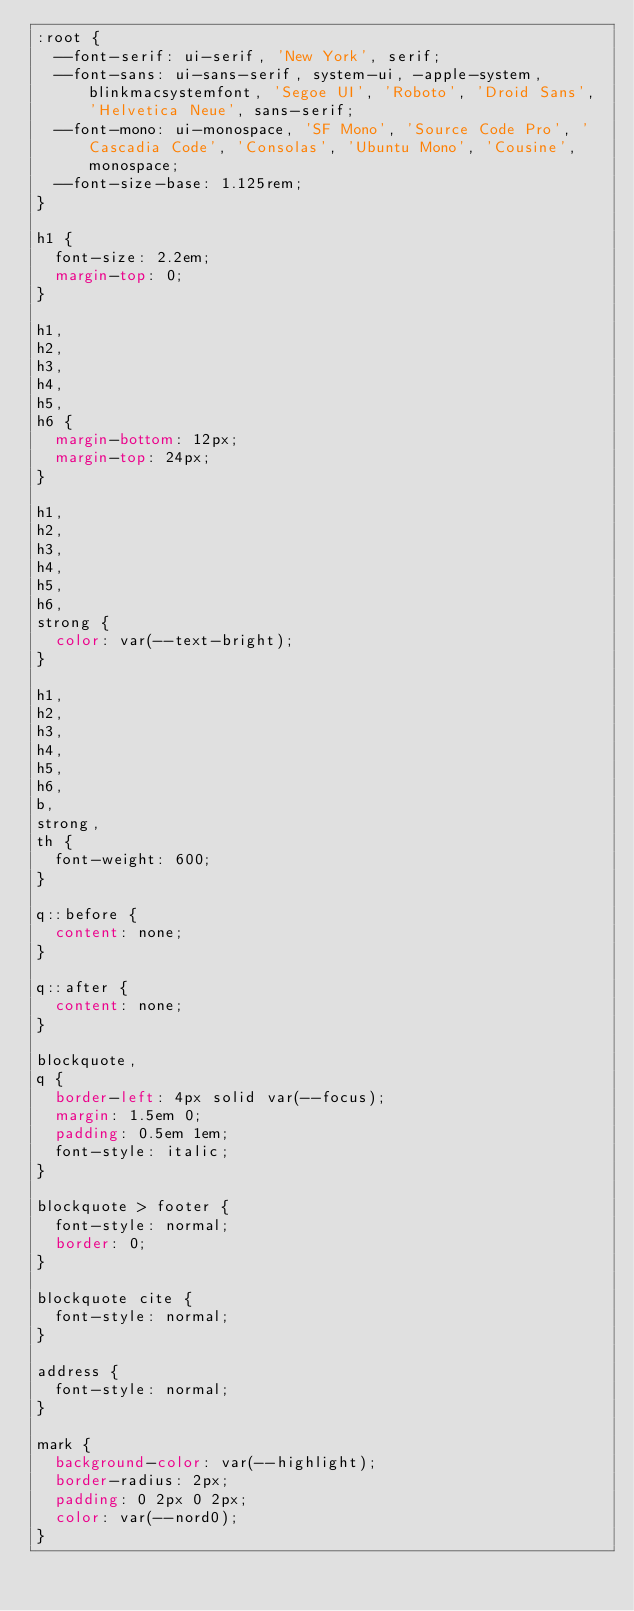Convert code to text. <code><loc_0><loc_0><loc_500><loc_500><_CSS_>:root {
  --font-serif: ui-serif, 'New York', serif;
  --font-sans: ui-sans-serif, system-ui, -apple-system, blinkmacsystemfont, 'Segoe UI', 'Roboto', 'Droid Sans', 'Helvetica Neue', sans-serif;
  --font-mono: ui-monospace, 'SF Mono', 'Source Code Pro', 'Cascadia Code', 'Consolas', 'Ubuntu Mono', 'Cousine', monospace;
  --font-size-base: 1.125rem;
}

h1 {
  font-size: 2.2em;
  margin-top: 0;
}

h1,
h2,
h3,
h4,
h5,
h6 {
  margin-bottom: 12px;
  margin-top: 24px;
}

h1,
h2,
h3,
h4,
h5,
h6,
strong {
  color: var(--text-bright);
}

h1,
h2,
h3,
h4,
h5,
h6,
b,
strong,
th {
  font-weight: 600;
}

q::before {
  content: none;
}

q::after {
  content: none;
}

blockquote,
q {
  border-left: 4px solid var(--focus);
  margin: 1.5em 0;
  padding: 0.5em 1em;
  font-style: italic;
}

blockquote > footer {
  font-style: normal;
  border: 0;
}

blockquote cite {
  font-style: normal;
}

address {
  font-style: normal;
}

mark {
  background-color: var(--highlight);
  border-radius: 2px;
  padding: 0 2px 0 2px;
  color: var(--nord0);
}
</code> 